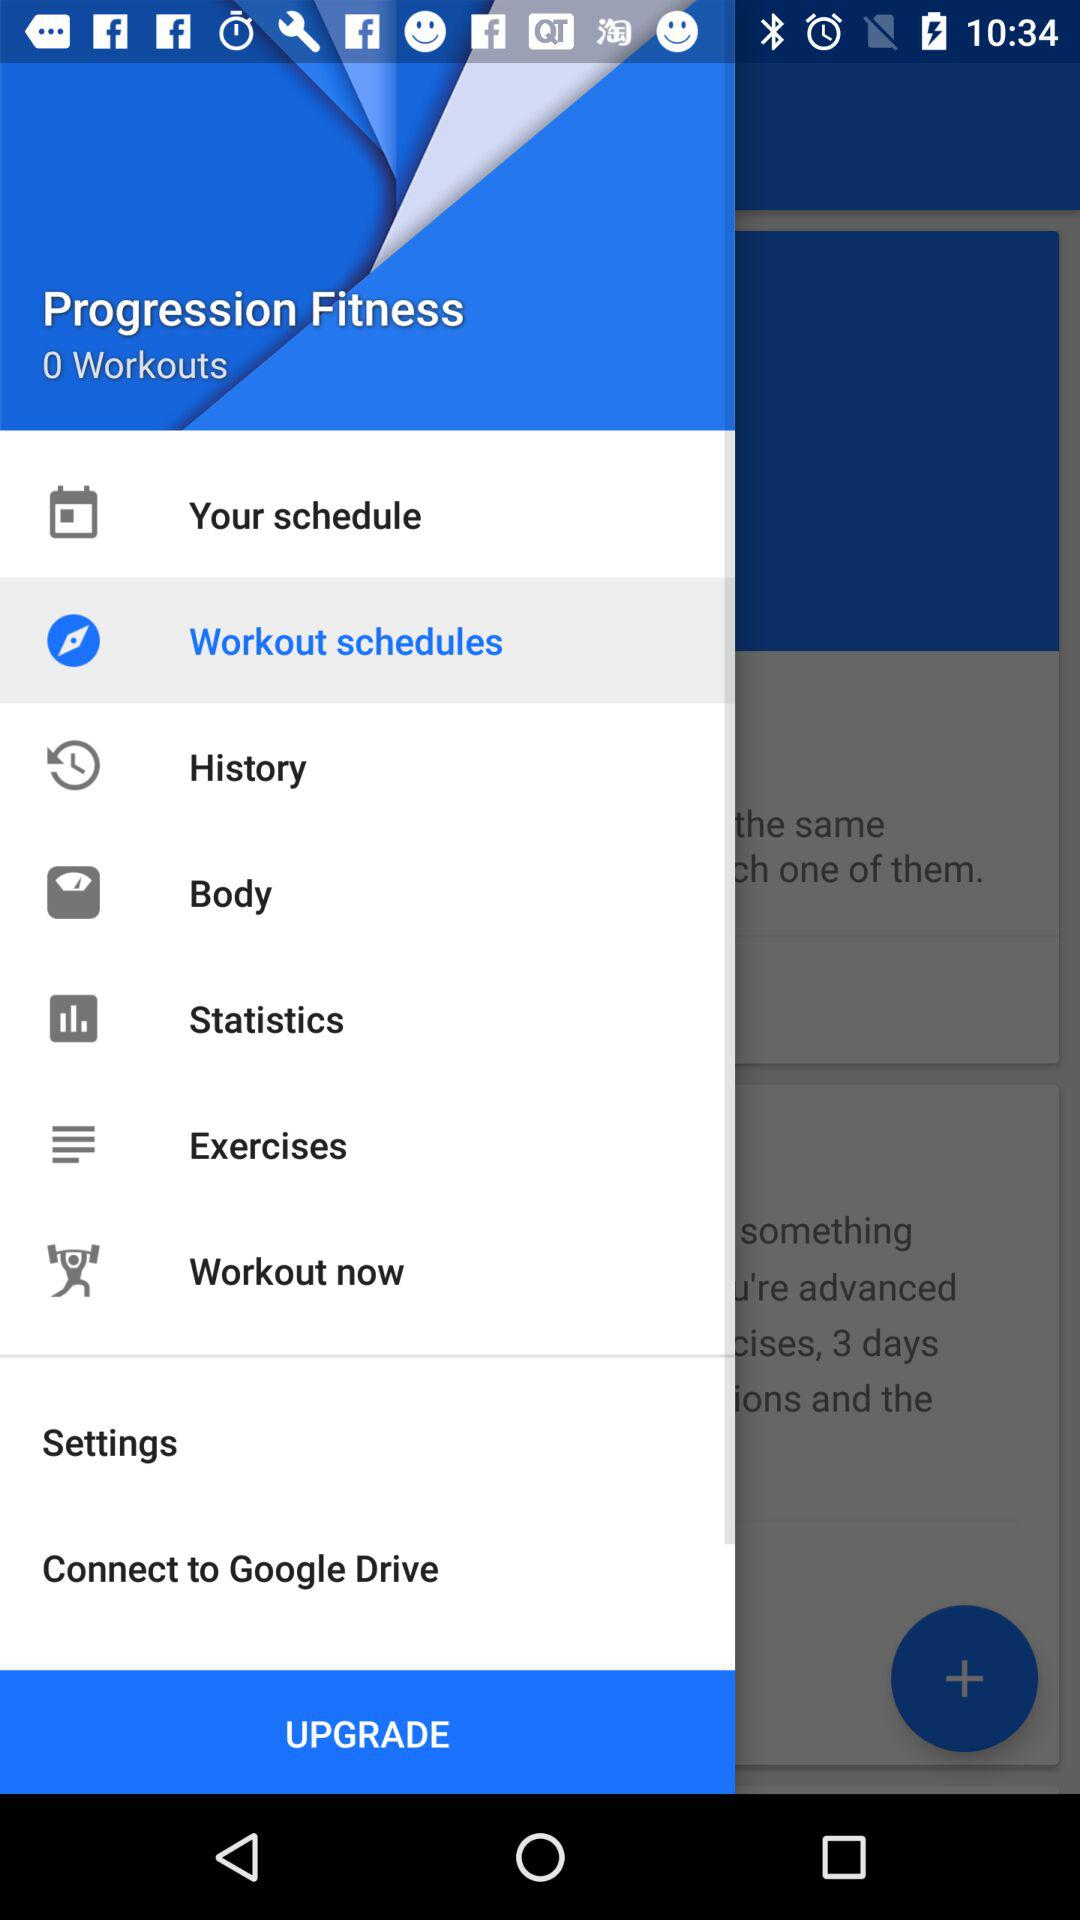How many workouts in total are there? There are 0 workouts in total. 